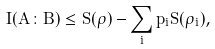Convert formula to latex. <formula><loc_0><loc_0><loc_500><loc_500>I ( A \colon B ) \leq S ( \rho ) - \sum _ { i } p _ { i } S ( \rho _ { i } ) ,</formula> 